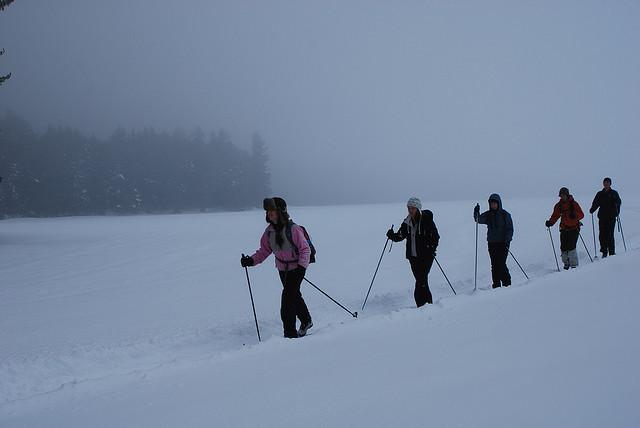Do they all have backpacks?
Write a very short answer. Yes. Is this a race?
Quick response, please. No. How many people are actually in the photo?
Keep it brief. 5. Are they actively skiing or standing?
Short answer required. Skiing. What color is the jacket in the front?
Answer briefly. Pink. Is this a sunny day?
Quick response, please. No. Are these people downhill skiing?
Write a very short answer. No. Are all the people skiing in the same direction?
Give a very brief answer. Yes. Is the snow deep?
Keep it brief. Yes. How many people are in this group?
Be succinct. 5. Can you rent skis at this location?
Short answer required. No. How many people are there?
Be succinct. 5. Is the wind blowing?
Short answer required. Yes. How did the people get here?
Concise answer only. Skiing. Is the landscape rocky or flat?
Short answer required. Flat. How many people are wearing white hats?
Be succinct. 1. 